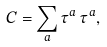Convert formula to latex. <formula><loc_0><loc_0><loc_500><loc_500>C = \sum _ { a } \tau ^ { a } \, \tau ^ { a } ,</formula> 